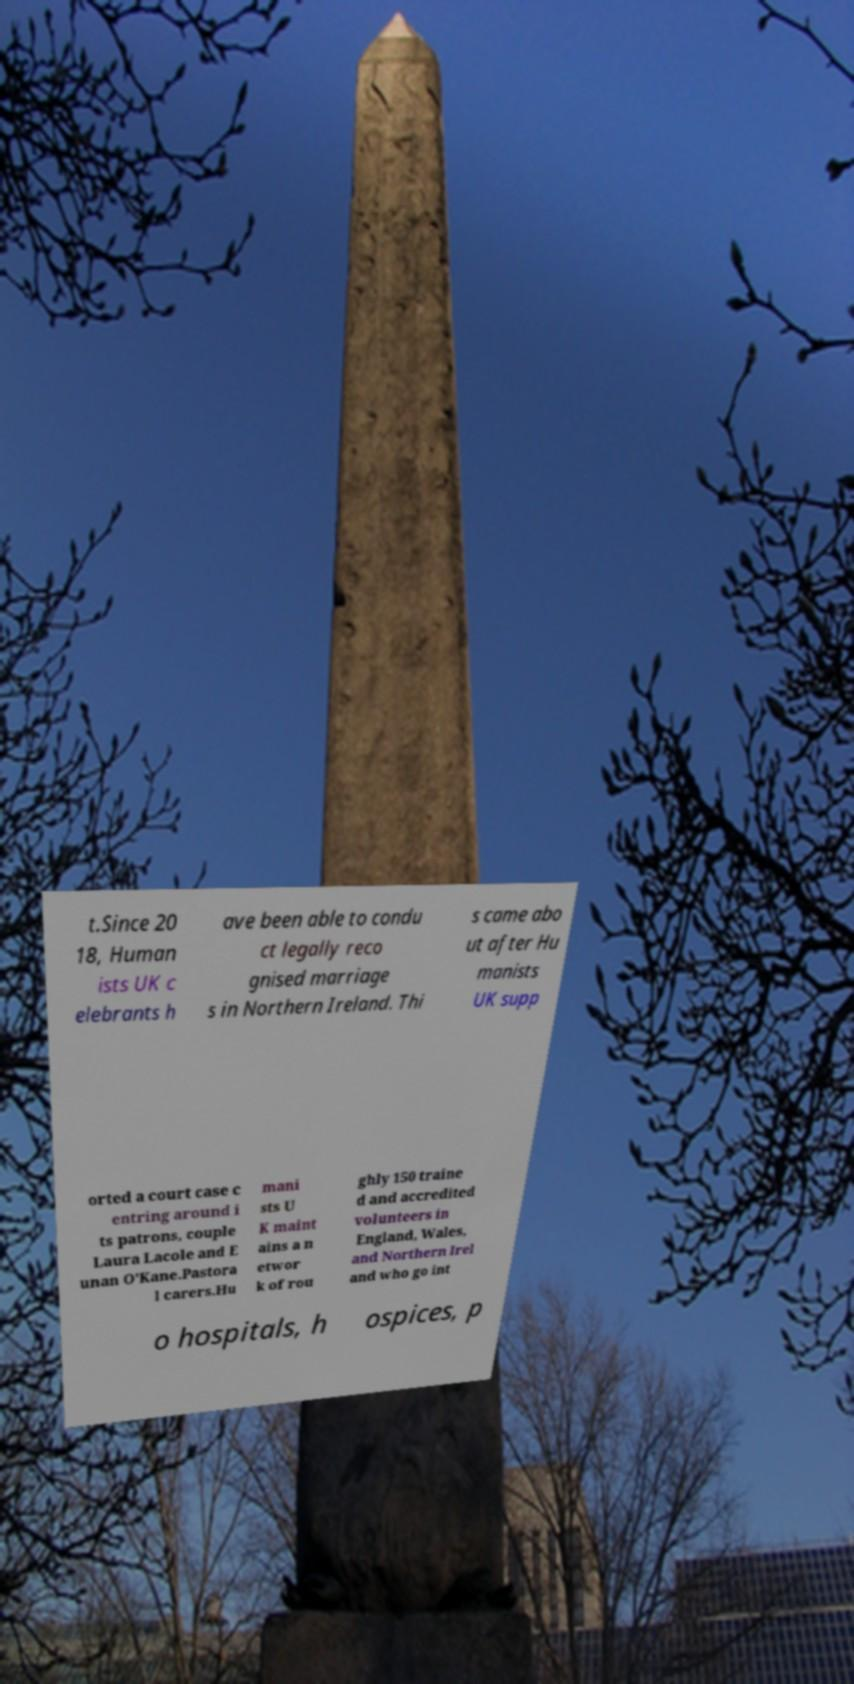Can you read and provide the text displayed in the image?This photo seems to have some interesting text. Can you extract and type it out for me? t.Since 20 18, Human ists UK c elebrants h ave been able to condu ct legally reco gnised marriage s in Northern Ireland. Thi s came abo ut after Hu manists UK supp orted a court case c entring around i ts patrons, couple Laura Lacole and E unan O'Kane.Pastora l carers.Hu mani sts U K maint ains a n etwor k of rou ghly 150 traine d and accredited volunteers in England, Wales, and Northern Irel and who go int o hospitals, h ospices, p 